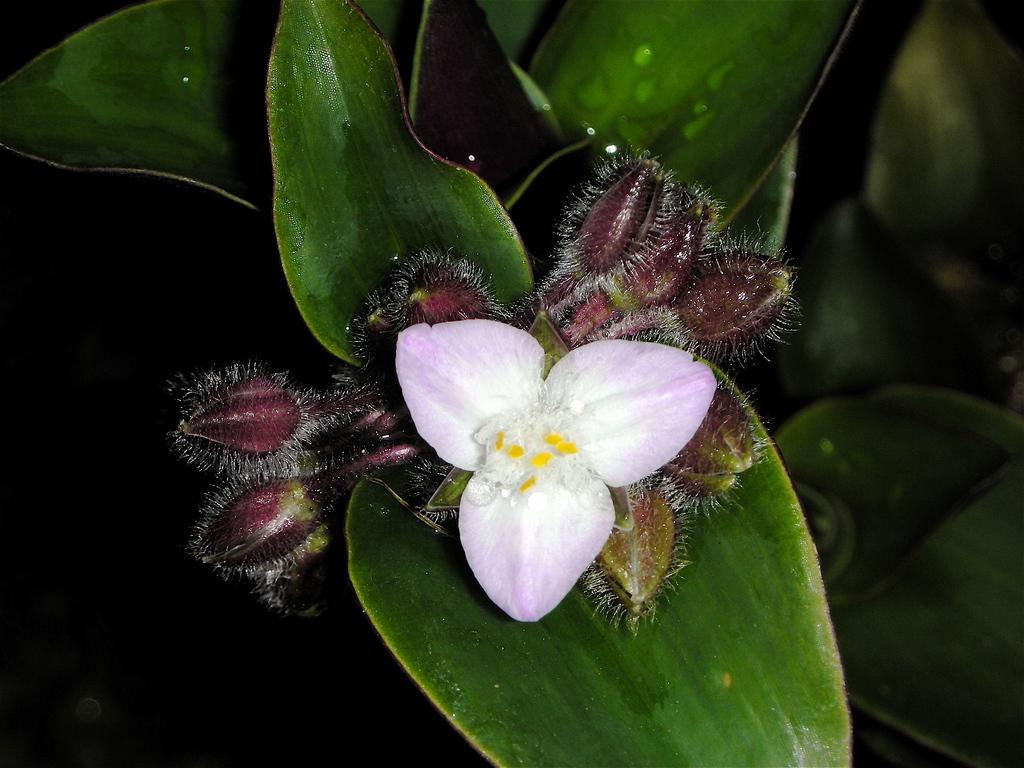What type of flower plant is in the image? There is a white cattleya orchid flower plant in the image. What advice does the flower plant give to the viewer in the image? The flower plant does not give any advice in the image, as it is an inanimate object and cannot communicate. 